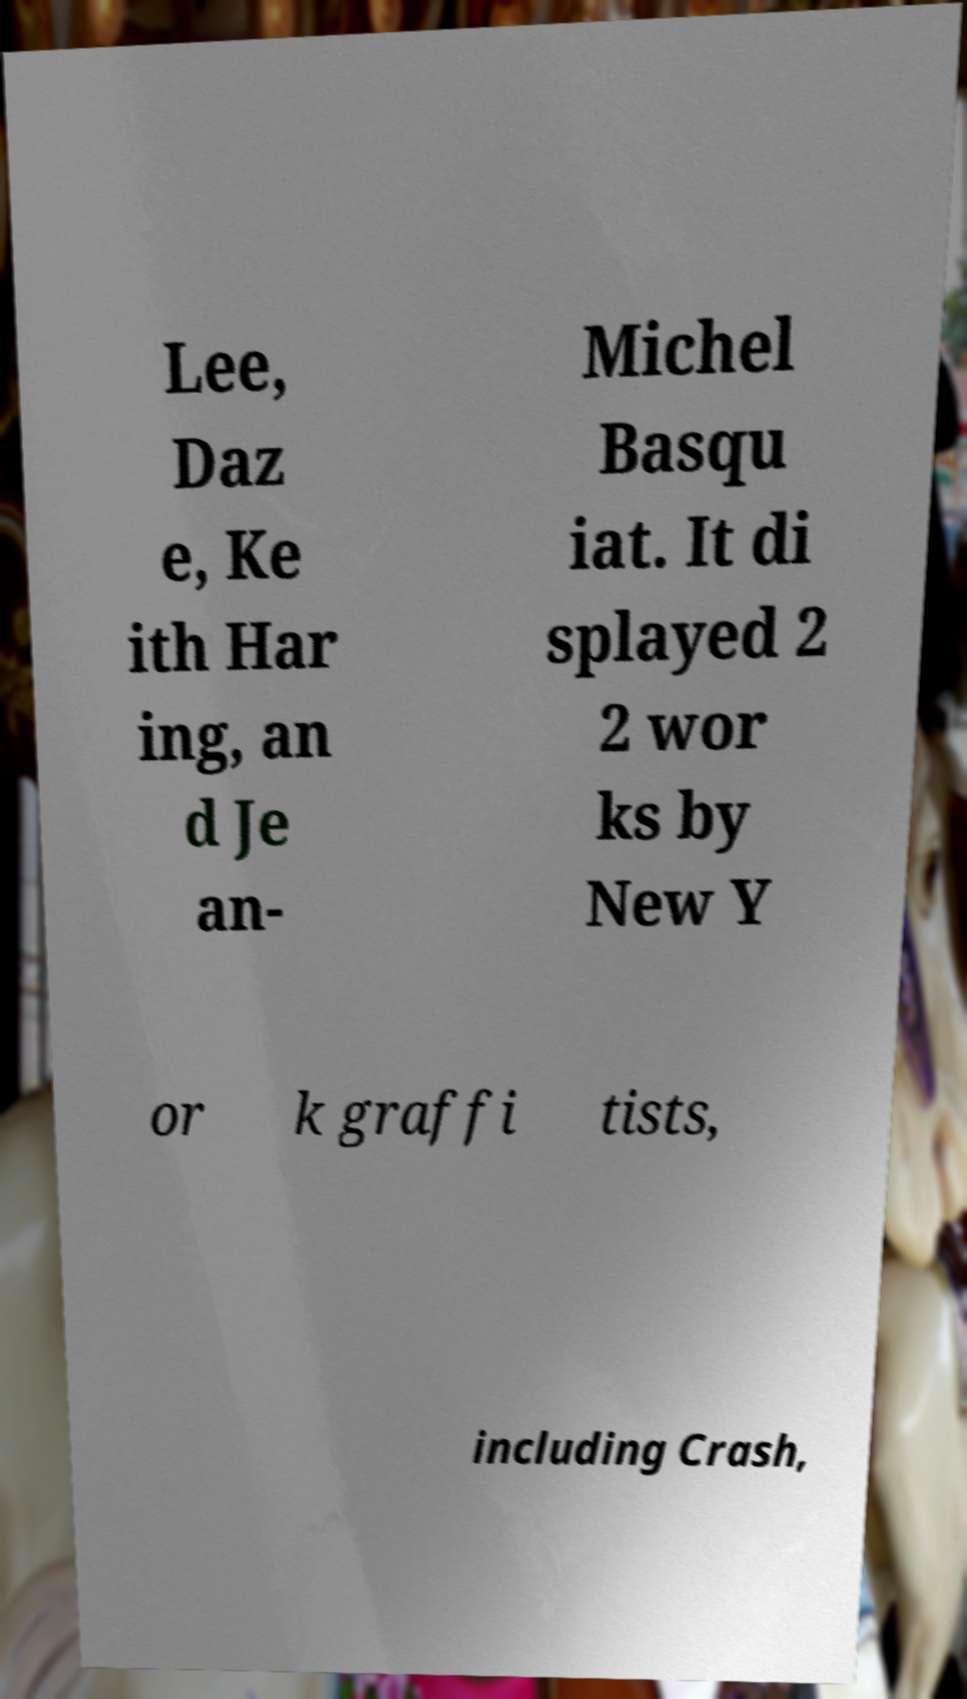Could you assist in decoding the text presented in this image and type it out clearly? Lee, Daz e, Ke ith Har ing, an d Je an- Michel Basqu iat. It di splayed 2 2 wor ks by New Y or k graffi tists, including Crash, 